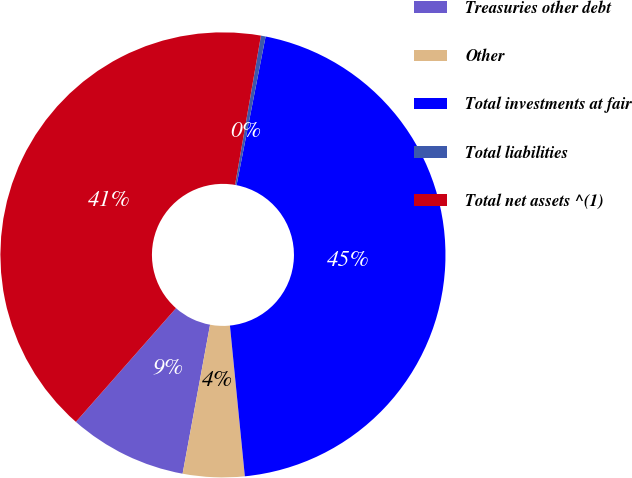<chart> <loc_0><loc_0><loc_500><loc_500><pie_chart><fcel>Treasuries other debt<fcel>Other<fcel>Total investments at fair<fcel>Total liabilities<fcel>Total net assets ^(1)<nl><fcel>8.59%<fcel>4.47%<fcel>45.36%<fcel>0.34%<fcel>41.24%<nl></chart> 